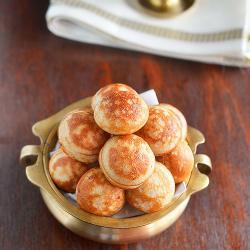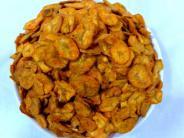The first image is the image on the left, the second image is the image on the right. For the images shown, is this caption "The chips in the image on the left are served with a side of red dipping sauce." true? Answer yes or no. No. The first image is the image on the left, the second image is the image on the right. Assess this claim about the two images: "The left image shows a fried treat served on a dark plate, with something in a smaller bowl nearby.". Correct or not? Answer yes or no. No. 